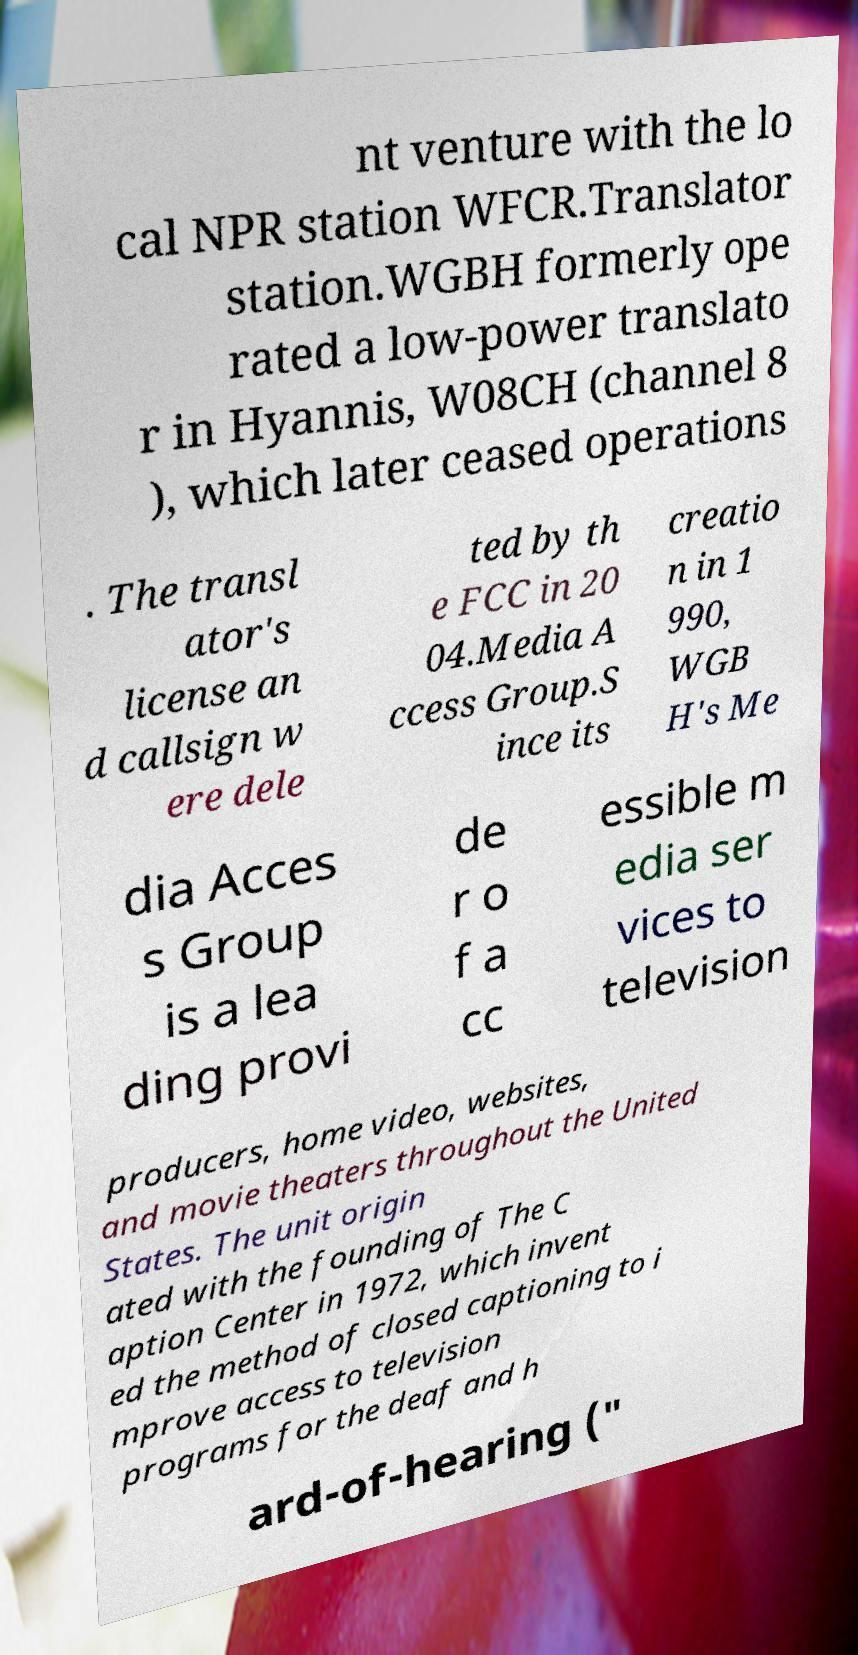I need the written content from this picture converted into text. Can you do that? nt venture with the lo cal NPR station WFCR.Translator station.WGBH formerly ope rated a low-power translato r in Hyannis, W08CH (channel 8 ), which later ceased operations . The transl ator's license an d callsign w ere dele ted by th e FCC in 20 04.Media A ccess Group.S ince its creatio n in 1 990, WGB H's Me dia Acces s Group is a lea ding provi de r o f a cc essible m edia ser vices to television producers, home video, websites, and movie theaters throughout the United States. The unit origin ated with the founding of The C aption Center in 1972, which invent ed the method of closed captioning to i mprove access to television programs for the deaf and h ard-of-hearing (" 